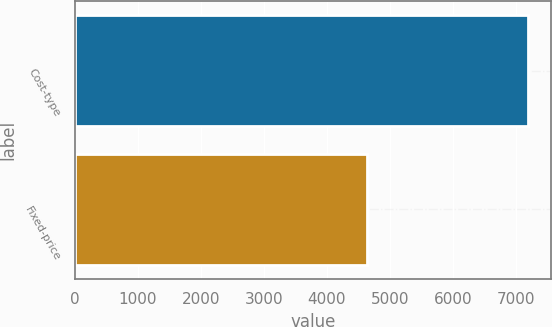<chart> <loc_0><loc_0><loc_500><loc_500><bar_chart><fcel>Cost-type<fcel>Fixed-price<nl><fcel>7193<fcel>4643<nl></chart> 